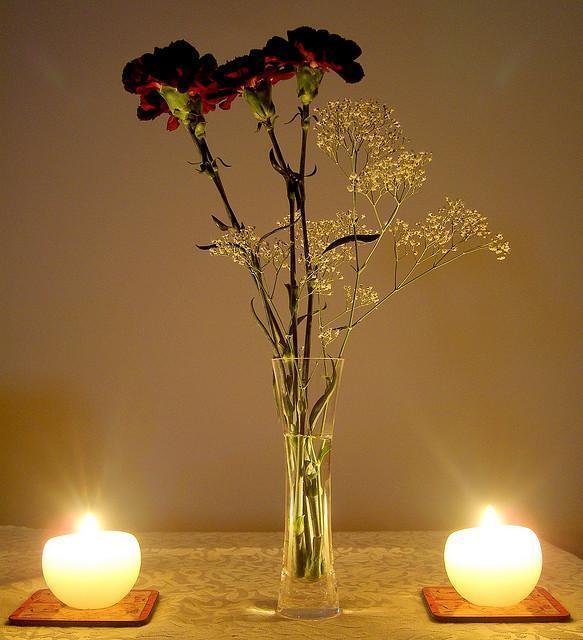How many candles are lit?
Give a very brief answer. 2. How many carnations are in the vase?
Give a very brief answer. 3. How many large bags is the old man holding?
Give a very brief answer. 0. 